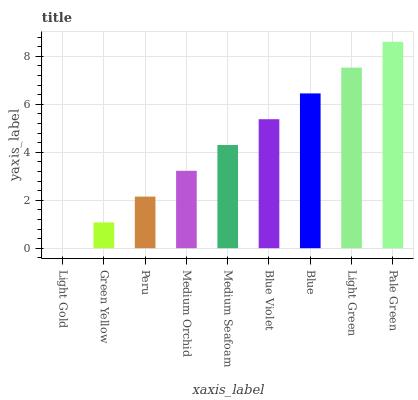Is Light Gold the minimum?
Answer yes or no. Yes. Is Pale Green the maximum?
Answer yes or no. Yes. Is Green Yellow the minimum?
Answer yes or no. No. Is Green Yellow the maximum?
Answer yes or no. No. Is Green Yellow greater than Light Gold?
Answer yes or no. Yes. Is Light Gold less than Green Yellow?
Answer yes or no. Yes. Is Light Gold greater than Green Yellow?
Answer yes or no. No. Is Green Yellow less than Light Gold?
Answer yes or no. No. Is Medium Seafoam the high median?
Answer yes or no. Yes. Is Medium Seafoam the low median?
Answer yes or no. Yes. Is Blue Violet the high median?
Answer yes or no. No. Is Peru the low median?
Answer yes or no. No. 